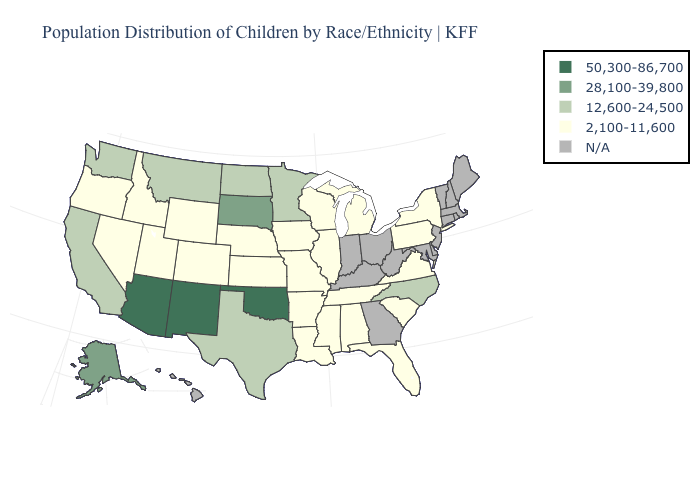Name the states that have a value in the range 2,100-11,600?
Answer briefly. Alabama, Arkansas, Colorado, Florida, Idaho, Illinois, Iowa, Kansas, Louisiana, Michigan, Mississippi, Missouri, Nebraska, Nevada, New York, Oregon, Pennsylvania, South Carolina, Tennessee, Utah, Virginia, Wisconsin, Wyoming. What is the value of South Dakota?
Give a very brief answer. 28,100-39,800. Name the states that have a value in the range 28,100-39,800?
Quick response, please. Alaska, South Dakota. Among the states that border South Dakota , which have the lowest value?
Give a very brief answer. Iowa, Nebraska, Wyoming. What is the value of Minnesota?
Concise answer only. 12,600-24,500. Which states hav the highest value in the MidWest?
Short answer required. South Dakota. Which states have the lowest value in the West?
Give a very brief answer. Colorado, Idaho, Nevada, Oregon, Utah, Wyoming. Name the states that have a value in the range 28,100-39,800?
Write a very short answer. Alaska, South Dakota. Name the states that have a value in the range 50,300-86,700?
Concise answer only. Arizona, New Mexico, Oklahoma. Among the states that border Nebraska , does Kansas have the lowest value?
Answer briefly. Yes. Does the map have missing data?
Answer briefly. Yes. How many symbols are there in the legend?
Be succinct. 5. Name the states that have a value in the range 2,100-11,600?
Answer briefly. Alabama, Arkansas, Colorado, Florida, Idaho, Illinois, Iowa, Kansas, Louisiana, Michigan, Mississippi, Missouri, Nebraska, Nevada, New York, Oregon, Pennsylvania, South Carolina, Tennessee, Utah, Virginia, Wisconsin, Wyoming. 